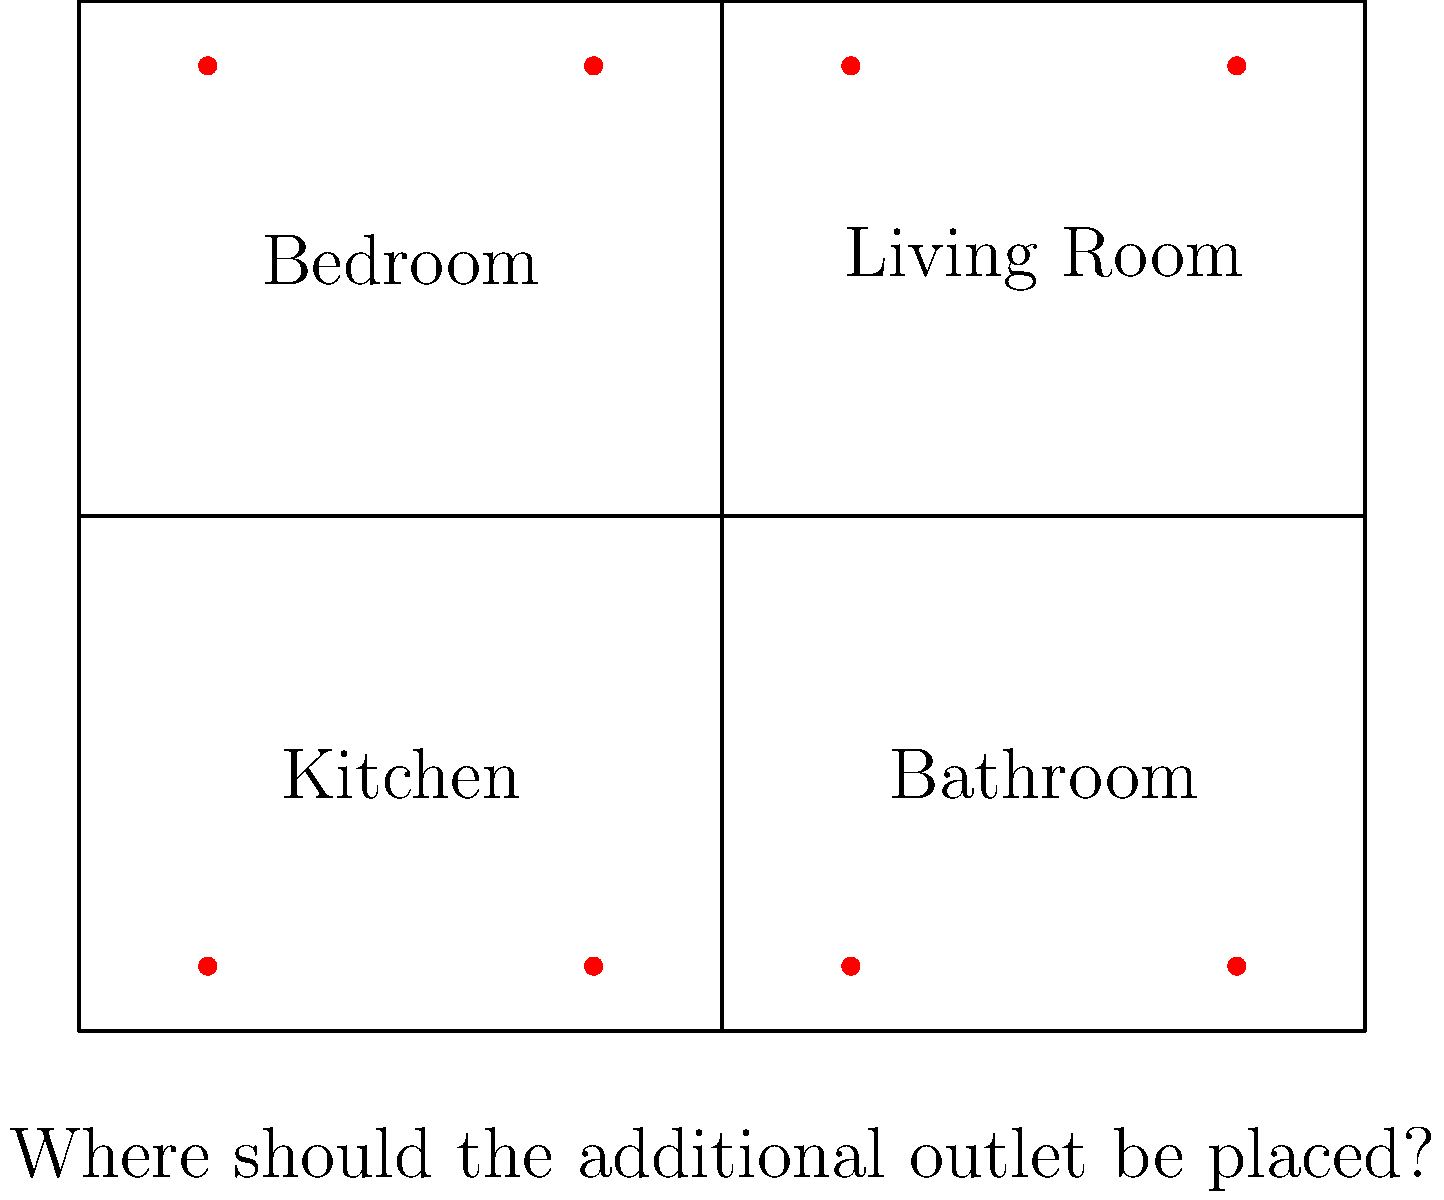After 20 years of marriage, you've decided to renovate your house. The floor plan above shows the current placement of electrical outlets (red dots). According to the National Electrical Code (NEC), receptacles should be placed so that no point along the floor line in any wall space is more than 6 feet from an outlet. Where should an additional outlet be placed to best comply with this requirement? To solve this problem, we need to follow these steps:

1. Understand the NEC requirement: No point along the floor line should be more than 6 feet from an outlet.

2. Analyze the current outlet placement:
   - Bedroom: Two outlets on the north wall
   - Living Room: Two outlets on the north wall
   - Kitchen: Two outlets on the south wall
   - Bathroom: Two outlets on the south wall

3. Identify the areas that might not meet the requirement:
   - The east and west walls of all rooms have no outlets
   - The longest wall without an outlet is the east wall of the bedroom and kitchen combined

4. Calculate the length of the east wall:
   - The house is 80 units tall
   - Each unit likely represents 1 foot
   - The east wall is 80 feet long

5. Determine the optimal placement:
   - To cover 80 feet with outlets no more than 12 feet apart (6 feet in each direction), we need an outlet in the middle
   - The middle point of the east wall is at 40 feet, which is the dividing line between the bedroom and kitchen

6. Consider practical factors:
   - Placing the outlet exactly on the room divider might be impractical
   - Slightly above or below the divider in either the bedroom or kitchen would be more suitable
   - The bedroom might benefit more from an additional outlet for items like lamps or phone chargers

Therefore, the best placement for the additional outlet would be on the east wall of the bedroom, slightly above the divider between the bedroom and kitchen.
Answer: East wall of bedroom, near kitchen divider 